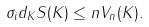Convert formula to latex. <formula><loc_0><loc_0><loc_500><loc_500>\sigma _ { i } d _ { K } S ( K ) \leq n V _ { n } ( K ) .</formula> 